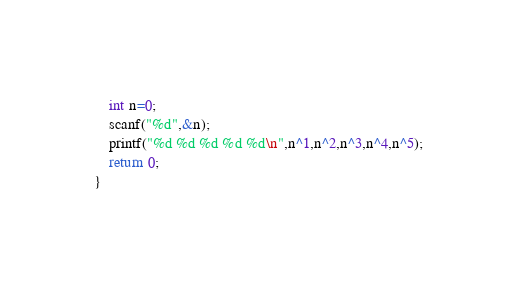Convert code to text. <code><loc_0><loc_0><loc_500><loc_500><_C++_>    int n=0;
    scanf("%d",&n);
    printf("%d %d %d %d %d\n",n^1,n^2,n^3,n^4,n^5);
    return 0;
}</code> 